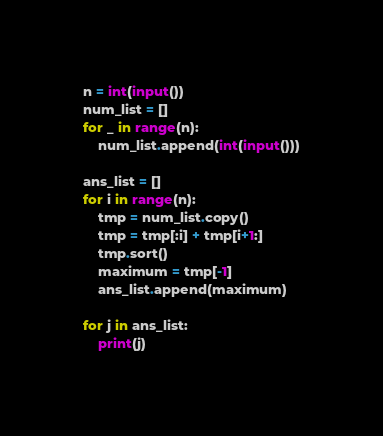<code> <loc_0><loc_0><loc_500><loc_500><_Python_>n = int(input())
num_list = []
for _ in range(n):
    num_list.append(int(input()))

ans_list = []
for i in range(n):
    tmp = num_list.copy()
    tmp = tmp[:i] + tmp[i+1:]
    tmp.sort()
    maximum = tmp[-1]
    ans_list.append(maximum)

for j in ans_list:
    print(j)</code> 